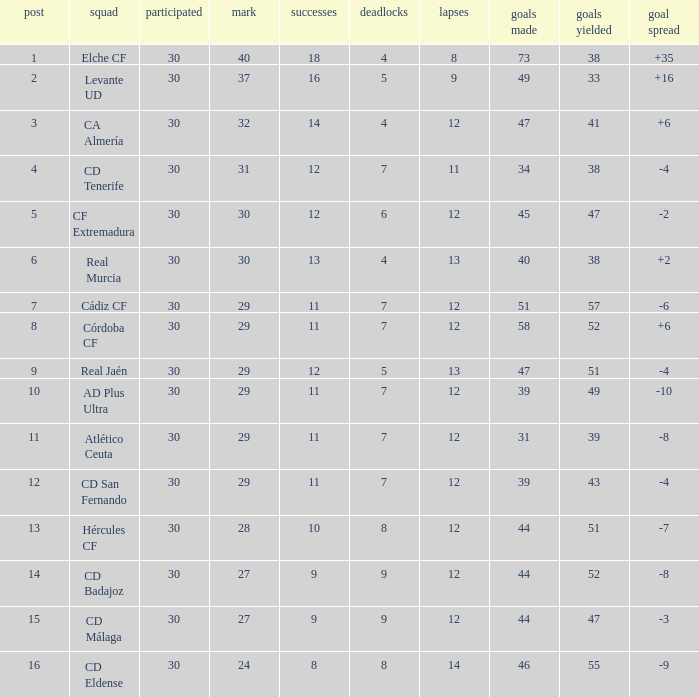What is the highest amount of goals with more than 51 goals against and less than 30 played? None. 